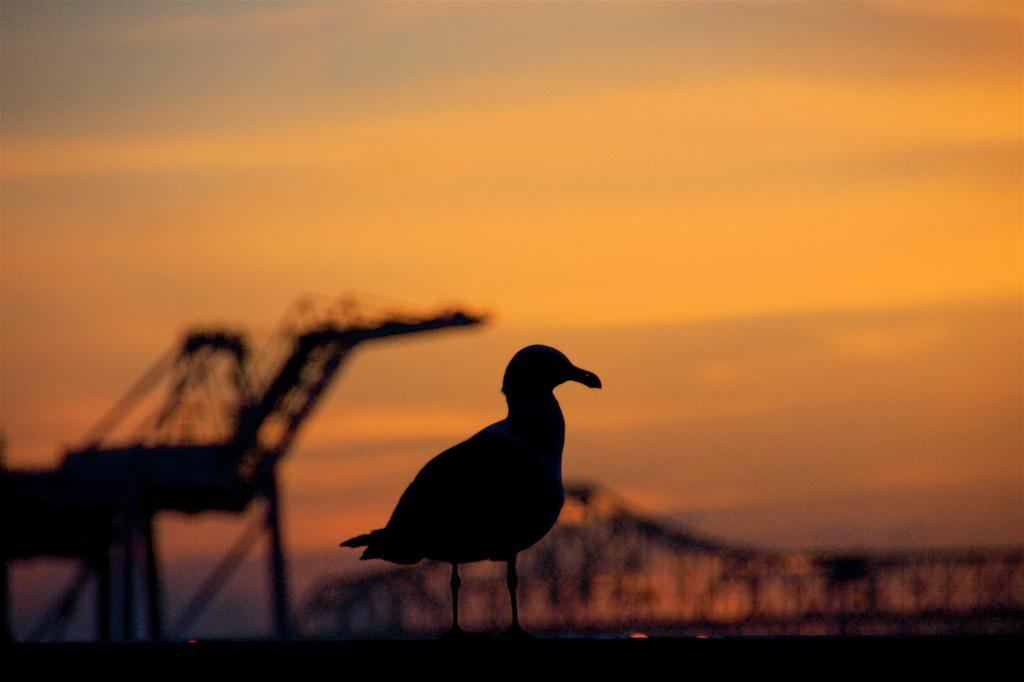What type of animal can be seen in the image? There is a bird in the image. What type of vegetation is visible in the image? There are trees visible in the image. What time of day is depicted in the image? The image depicts a sunset. What is the condition of the bird in the image? The image does not provide information about the bird's condition, only that it is present in the image. 